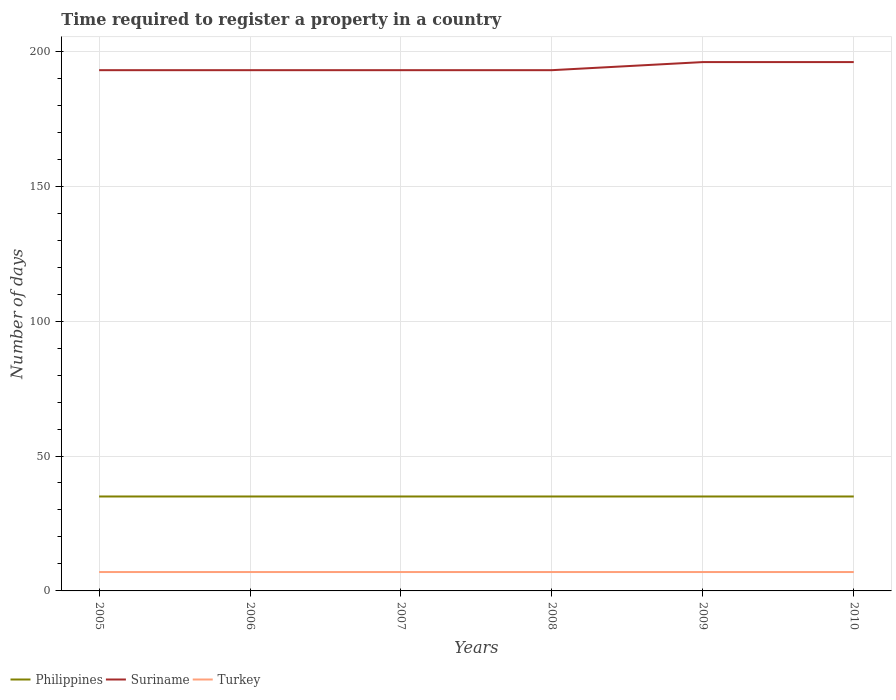How many different coloured lines are there?
Offer a very short reply. 3. Does the line corresponding to Philippines intersect with the line corresponding to Turkey?
Offer a terse response. No. Across all years, what is the maximum number of days required to register a property in Turkey?
Your response must be concise. 7. How many lines are there?
Your response must be concise. 3. How many years are there in the graph?
Keep it short and to the point. 6. What is the difference between two consecutive major ticks on the Y-axis?
Your answer should be compact. 50. Are the values on the major ticks of Y-axis written in scientific E-notation?
Keep it short and to the point. No. Does the graph contain grids?
Provide a succinct answer. Yes. Where does the legend appear in the graph?
Offer a terse response. Bottom left. How many legend labels are there?
Ensure brevity in your answer.  3. How are the legend labels stacked?
Your answer should be very brief. Horizontal. What is the title of the graph?
Keep it short and to the point. Time required to register a property in a country. What is the label or title of the X-axis?
Provide a succinct answer. Years. What is the label or title of the Y-axis?
Provide a succinct answer. Number of days. What is the Number of days in Philippines in 2005?
Your response must be concise. 35. What is the Number of days in Suriname in 2005?
Make the answer very short. 193. What is the Number of days in Turkey in 2005?
Ensure brevity in your answer.  7. What is the Number of days of Philippines in 2006?
Offer a very short reply. 35. What is the Number of days of Suriname in 2006?
Make the answer very short. 193. What is the Number of days of Turkey in 2006?
Your answer should be compact. 7. What is the Number of days of Suriname in 2007?
Your answer should be very brief. 193. What is the Number of days in Turkey in 2007?
Provide a succinct answer. 7. What is the Number of days in Philippines in 2008?
Give a very brief answer. 35. What is the Number of days in Suriname in 2008?
Your answer should be very brief. 193. What is the Number of days in Turkey in 2008?
Your answer should be compact. 7. What is the Number of days in Suriname in 2009?
Your answer should be compact. 196. What is the Number of days of Suriname in 2010?
Your response must be concise. 196. What is the Number of days of Turkey in 2010?
Make the answer very short. 7. Across all years, what is the maximum Number of days in Philippines?
Your answer should be compact. 35. Across all years, what is the maximum Number of days in Suriname?
Keep it short and to the point. 196. Across all years, what is the maximum Number of days of Turkey?
Ensure brevity in your answer.  7. Across all years, what is the minimum Number of days of Suriname?
Ensure brevity in your answer.  193. What is the total Number of days in Philippines in the graph?
Offer a terse response. 210. What is the total Number of days of Suriname in the graph?
Keep it short and to the point. 1164. What is the difference between the Number of days of Philippines in 2005 and that in 2006?
Make the answer very short. 0. What is the difference between the Number of days of Suriname in 2005 and that in 2006?
Give a very brief answer. 0. What is the difference between the Number of days in Turkey in 2005 and that in 2006?
Provide a short and direct response. 0. What is the difference between the Number of days in Philippines in 2005 and that in 2007?
Offer a terse response. 0. What is the difference between the Number of days of Suriname in 2005 and that in 2007?
Your response must be concise. 0. What is the difference between the Number of days in Philippines in 2005 and that in 2008?
Ensure brevity in your answer.  0. What is the difference between the Number of days of Suriname in 2005 and that in 2008?
Provide a short and direct response. 0. What is the difference between the Number of days in Turkey in 2005 and that in 2008?
Make the answer very short. 0. What is the difference between the Number of days in Philippines in 2005 and that in 2009?
Your answer should be compact. 0. What is the difference between the Number of days in Suriname in 2006 and that in 2007?
Your answer should be compact. 0. What is the difference between the Number of days in Turkey in 2006 and that in 2007?
Your answer should be very brief. 0. What is the difference between the Number of days in Turkey in 2006 and that in 2008?
Offer a terse response. 0. What is the difference between the Number of days in Philippines in 2006 and that in 2009?
Your answer should be very brief. 0. What is the difference between the Number of days in Turkey in 2006 and that in 2009?
Make the answer very short. 0. What is the difference between the Number of days in Turkey in 2006 and that in 2010?
Your answer should be compact. 0. What is the difference between the Number of days in Suriname in 2007 and that in 2008?
Your answer should be very brief. 0. What is the difference between the Number of days of Turkey in 2007 and that in 2008?
Your response must be concise. 0. What is the difference between the Number of days in Philippines in 2007 and that in 2009?
Your answer should be compact. 0. What is the difference between the Number of days in Suriname in 2007 and that in 2009?
Provide a succinct answer. -3. What is the difference between the Number of days of Philippines in 2007 and that in 2010?
Give a very brief answer. 0. What is the difference between the Number of days of Suriname in 2007 and that in 2010?
Give a very brief answer. -3. What is the difference between the Number of days in Suriname in 2008 and that in 2009?
Your answer should be very brief. -3. What is the difference between the Number of days of Philippines in 2008 and that in 2010?
Keep it short and to the point. 0. What is the difference between the Number of days in Turkey in 2008 and that in 2010?
Your answer should be very brief. 0. What is the difference between the Number of days in Suriname in 2009 and that in 2010?
Ensure brevity in your answer.  0. What is the difference between the Number of days in Turkey in 2009 and that in 2010?
Keep it short and to the point. 0. What is the difference between the Number of days in Philippines in 2005 and the Number of days in Suriname in 2006?
Your answer should be compact. -158. What is the difference between the Number of days in Suriname in 2005 and the Number of days in Turkey in 2006?
Keep it short and to the point. 186. What is the difference between the Number of days of Philippines in 2005 and the Number of days of Suriname in 2007?
Keep it short and to the point. -158. What is the difference between the Number of days in Suriname in 2005 and the Number of days in Turkey in 2007?
Give a very brief answer. 186. What is the difference between the Number of days of Philippines in 2005 and the Number of days of Suriname in 2008?
Give a very brief answer. -158. What is the difference between the Number of days in Suriname in 2005 and the Number of days in Turkey in 2008?
Give a very brief answer. 186. What is the difference between the Number of days of Philippines in 2005 and the Number of days of Suriname in 2009?
Make the answer very short. -161. What is the difference between the Number of days of Suriname in 2005 and the Number of days of Turkey in 2009?
Offer a terse response. 186. What is the difference between the Number of days in Philippines in 2005 and the Number of days in Suriname in 2010?
Provide a succinct answer. -161. What is the difference between the Number of days of Suriname in 2005 and the Number of days of Turkey in 2010?
Offer a very short reply. 186. What is the difference between the Number of days in Philippines in 2006 and the Number of days in Suriname in 2007?
Keep it short and to the point. -158. What is the difference between the Number of days in Suriname in 2006 and the Number of days in Turkey in 2007?
Ensure brevity in your answer.  186. What is the difference between the Number of days in Philippines in 2006 and the Number of days in Suriname in 2008?
Provide a short and direct response. -158. What is the difference between the Number of days in Suriname in 2006 and the Number of days in Turkey in 2008?
Your response must be concise. 186. What is the difference between the Number of days in Philippines in 2006 and the Number of days in Suriname in 2009?
Your response must be concise. -161. What is the difference between the Number of days of Suriname in 2006 and the Number of days of Turkey in 2009?
Give a very brief answer. 186. What is the difference between the Number of days of Philippines in 2006 and the Number of days of Suriname in 2010?
Offer a very short reply. -161. What is the difference between the Number of days of Suriname in 2006 and the Number of days of Turkey in 2010?
Your answer should be compact. 186. What is the difference between the Number of days of Philippines in 2007 and the Number of days of Suriname in 2008?
Provide a succinct answer. -158. What is the difference between the Number of days of Suriname in 2007 and the Number of days of Turkey in 2008?
Provide a succinct answer. 186. What is the difference between the Number of days in Philippines in 2007 and the Number of days in Suriname in 2009?
Your answer should be compact. -161. What is the difference between the Number of days of Suriname in 2007 and the Number of days of Turkey in 2009?
Your response must be concise. 186. What is the difference between the Number of days in Philippines in 2007 and the Number of days in Suriname in 2010?
Your answer should be compact. -161. What is the difference between the Number of days of Suriname in 2007 and the Number of days of Turkey in 2010?
Offer a terse response. 186. What is the difference between the Number of days in Philippines in 2008 and the Number of days in Suriname in 2009?
Provide a succinct answer. -161. What is the difference between the Number of days in Philippines in 2008 and the Number of days in Turkey in 2009?
Provide a succinct answer. 28. What is the difference between the Number of days of Suriname in 2008 and the Number of days of Turkey in 2009?
Your answer should be very brief. 186. What is the difference between the Number of days in Philippines in 2008 and the Number of days in Suriname in 2010?
Provide a short and direct response. -161. What is the difference between the Number of days of Suriname in 2008 and the Number of days of Turkey in 2010?
Provide a succinct answer. 186. What is the difference between the Number of days in Philippines in 2009 and the Number of days in Suriname in 2010?
Your answer should be compact. -161. What is the difference between the Number of days in Philippines in 2009 and the Number of days in Turkey in 2010?
Give a very brief answer. 28. What is the difference between the Number of days of Suriname in 2009 and the Number of days of Turkey in 2010?
Ensure brevity in your answer.  189. What is the average Number of days in Suriname per year?
Give a very brief answer. 194. What is the average Number of days of Turkey per year?
Give a very brief answer. 7. In the year 2005, what is the difference between the Number of days in Philippines and Number of days in Suriname?
Provide a short and direct response. -158. In the year 2005, what is the difference between the Number of days of Philippines and Number of days of Turkey?
Offer a very short reply. 28. In the year 2005, what is the difference between the Number of days in Suriname and Number of days in Turkey?
Your answer should be very brief. 186. In the year 2006, what is the difference between the Number of days of Philippines and Number of days of Suriname?
Offer a terse response. -158. In the year 2006, what is the difference between the Number of days in Suriname and Number of days in Turkey?
Give a very brief answer. 186. In the year 2007, what is the difference between the Number of days of Philippines and Number of days of Suriname?
Offer a terse response. -158. In the year 2007, what is the difference between the Number of days in Suriname and Number of days in Turkey?
Your answer should be compact. 186. In the year 2008, what is the difference between the Number of days in Philippines and Number of days in Suriname?
Provide a short and direct response. -158. In the year 2008, what is the difference between the Number of days of Philippines and Number of days of Turkey?
Provide a succinct answer. 28. In the year 2008, what is the difference between the Number of days of Suriname and Number of days of Turkey?
Give a very brief answer. 186. In the year 2009, what is the difference between the Number of days of Philippines and Number of days of Suriname?
Make the answer very short. -161. In the year 2009, what is the difference between the Number of days of Philippines and Number of days of Turkey?
Offer a terse response. 28. In the year 2009, what is the difference between the Number of days of Suriname and Number of days of Turkey?
Your answer should be very brief. 189. In the year 2010, what is the difference between the Number of days of Philippines and Number of days of Suriname?
Provide a succinct answer. -161. In the year 2010, what is the difference between the Number of days in Suriname and Number of days in Turkey?
Provide a succinct answer. 189. What is the ratio of the Number of days in Philippines in 2005 to that in 2006?
Provide a short and direct response. 1. What is the ratio of the Number of days of Suriname in 2005 to that in 2006?
Your answer should be very brief. 1. What is the ratio of the Number of days in Turkey in 2005 to that in 2006?
Offer a very short reply. 1. What is the ratio of the Number of days in Suriname in 2005 to that in 2007?
Your response must be concise. 1. What is the ratio of the Number of days of Turkey in 2005 to that in 2007?
Keep it short and to the point. 1. What is the ratio of the Number of days in Philippines in 2005 to that in 2008?
Give a very brief answer. 1. What is the ratio of the Number of days of Suriname in 2005 to that in 2008?
Provide a succinct answer. 1. What is the ratio of the Number of days of Turkey in 2005 to that in 2008?
Your answer should be compact. 1. What is the ratio of the Number of days of Philippines in 2005 to that in 2009?
Provide a short and direct response. 1. What is the ratio of the Number of days in Suriname in 2005 to that in 2009?
Your response must be concise. 0.98. What is the ratio of the Number of days in Turkey in 2005 to that in 2009?
Your answer should be compact. 1. What is the ratio of the Number of days in Suriname in 2005 to that in 2010?
Provide a succinct answer. 0.98. What is the ratio of the Number of days in Turkey in 2005 to that in 2010?
Offer a very short reply. 1. What is the ratio of the Number of days in Turkey in 2006 to that in 2007?
Make the answer very short. 1. What is the ratio of the Number of days of Turkey in 2006 to that in 2008?
Ensure brevity in your answer.  1. What is the ratio of the Number of days of Philippines in 2006 to that in 2009?
Offer a terse response. 1. What is the ratio of the Number of days of Suriname in 2006 to that in 2009?
Your response must be concise. 0.98. What is the ratio of the Number of days of Turkey in 2006 to that in 2009?
Your answer should be very brief. 1. What is the ratio of the Number of days of Suriname in 2006 to that in 2010?
Provide a succinct answer. 0.98. What is the ratio of the Number of days in Philippines in 2007 to that in 2008?
Keep it short and to the point. 1. What is the ratio of the Number of days of Turkey in 2007 to that in 2008?
Your answer should be very brief. 1. What is the ratio of the Number of days of Philippines in 2007 to that in 2009?
Offer a very short reply. 1. What is the ratio of the Number of days in Suriname in 2007 to that in 2009?
Ensure brevity in your answer.  0.98. What is the ratio of the Number of days of Turkey in 2007 to that in 2009?
Your response must be concise. 1. What is the ratio of the Number of days in Philippines in 2007 to that in 2010?
Your answer should be compact. 1. What is the ratio of the Number of days of Suriname in 2007 to that in 2010?
Offer a very short reply. 0.98. What is the ratio of the Number of days of Turkey in 2007 to that in 2010?
Give a very brief answer. 1. What is the ratio of the Number of days in Suriname in 2008 to that in 2009?
Provide a succinct answer. 0.98. What is the ratio of the Number of days in Philippines in 2008 to that in 2010?
Offer a terse response. 1. What is the ratio of the Number of days in Suriname in 2008 to that in 2010?
Give a very brief answer. 0.98. What is the ratio of the Number of days in Suriname in 2009 to that in 2010?
Your answer should be compact. 1. What is the ratio of the Number of days of Turkey in 2009 to that in 2010?
Your response must be concise. 1. What is the difference between the highest and the second highest Number of days of Suriname?
Provide a short and direct response. 0. What is the difference between the highest and the lowest Number of days of Turkey?
Your response must be concise. 0. 